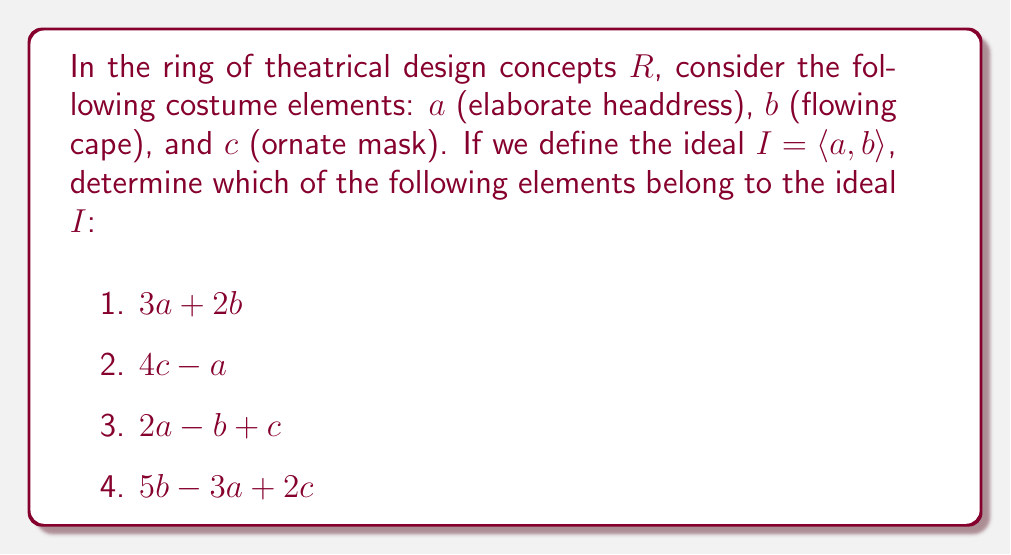Teach me how to tackle this problem. To solve this problem, we need to understand what an ideal generated by specific elements in a ring means and how to determine if an element belongs to that ideal.

1) An ideal $I = \langle a, b \rangle$ in a ring $R$ is the set of all elements that can be expressed as linear combinations of $a$ and $b$ with coefficients from $R$. In other words, any element in $I$ can be written as $ra + sb$, where $r, s \in R$.

2) To check if an element belongs to the ideal, we need to see if it can be expressed as a linear combination of the generators ($a$ and $b$ in this case).

Let's examine each element:

1. $3a + 2b$: This is clearly a linear combination of $a$ and $b$, so it belongs to $I$.

2. $4c - a$: This contains $c$, which is not a generator of $I$. The presence of $-a$ doesn't change this fact. Therefore, it does not belong to $I$.

3. $2a - b + c$: This also contains $c$, which is not a generator of $I$. Even though it has terms with $a$ and $b$, the presence of $c$ means it's not in $I$.

4. $5b - 3a + 2c$: Again, this contains $c$, which is not a generator of $I$. Despite having terms with $a$ and $b$, the presence of $c$ means it's not in $I$.

In the context of theatrical design, we can interpret this as saying that any costume concept that only involves combinations of the elaborate headdress and flowing cape (our generators $a$ and $b$) is part of the ideal. However, any concept that introduces the ornate mask ($c$) or any other element not in our generating set cannot be part of this ideal.
Answer: Only the element $3a + 2b$ belongs to the ideal $I = \langle a, b \rangle$. 